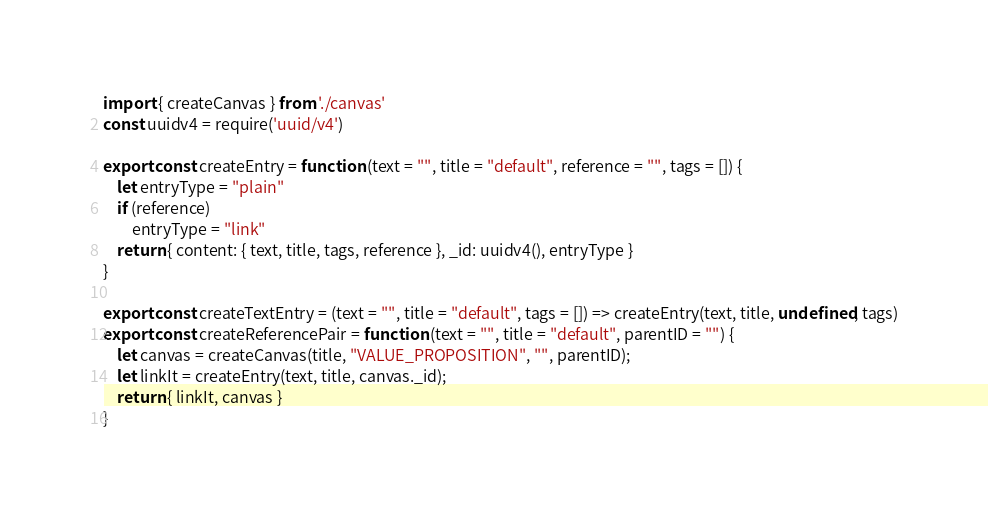<code> <loc_0><loc_0><loc_500><loc_500><_JavaScript_>import { createCanvas } from './canvas'
const uuidv4 = require('uuid/v4')

export const createEntry = function (text = "", title = "default", reference = "", tags = []) {
    let entryType = "plain"
    if (reference)
        entryType = "link"
    return { content: { text, title, tags, reference }, _id: uuidv4(), entryType }
}

export const createTextEntry = (text = "", title = "default", tags = []) => createEntry(text, title, undefined, tags)
export const createReferencePair = function (text = "", title = "default", parentID = "") {
    let canvas = createCanvas(title, "VALUE_PROPOSITION", "", parentID);
    let linkIt = createEntry(text, title, canvas._id);
    return { linkIt, canvas }
}
</code> 